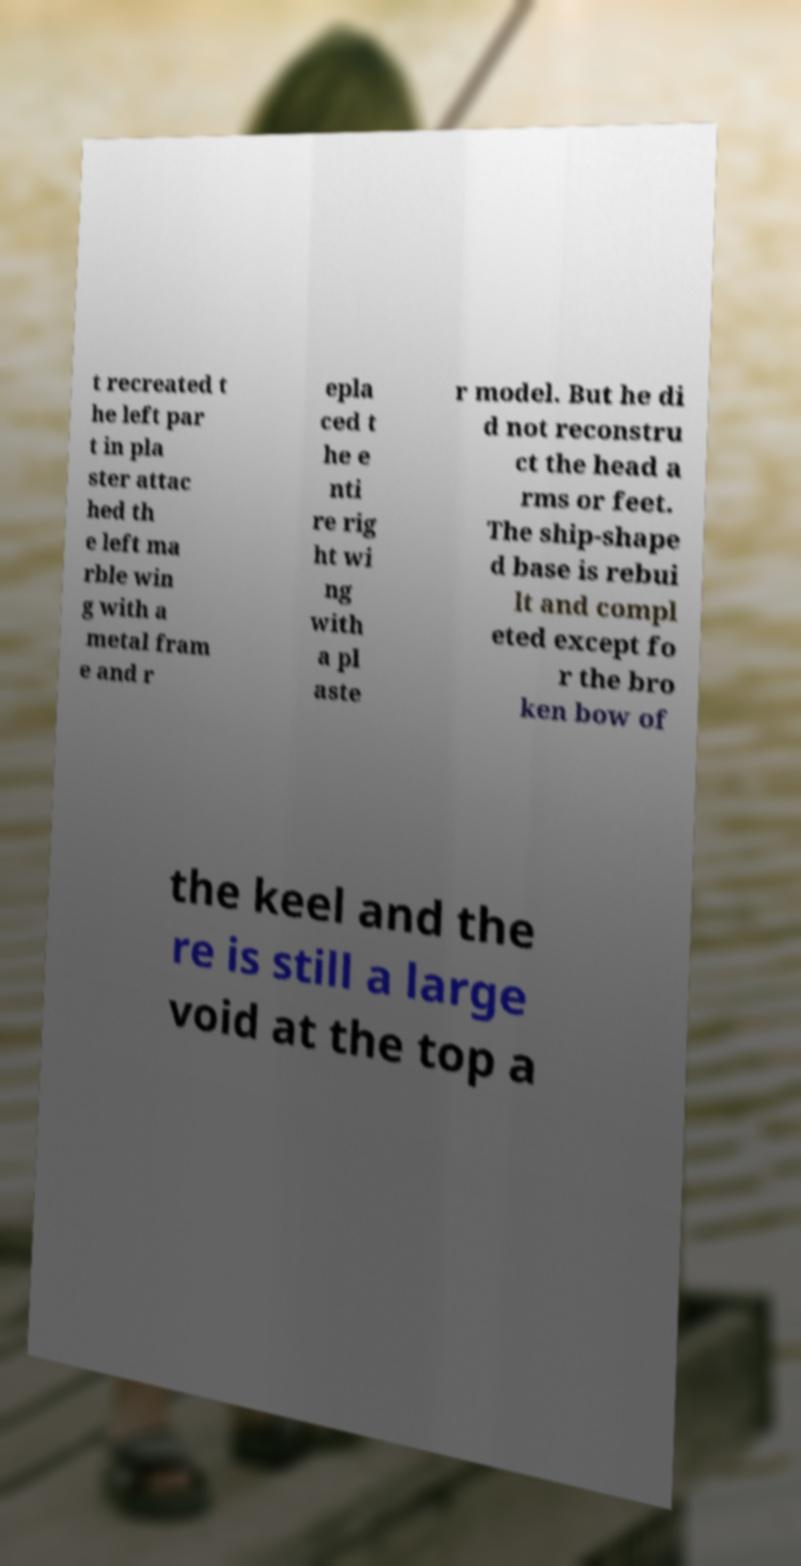For documentation purposes, I need the text within this image transcribed. Could you provide that? t recreated t he left par t in pla ster attac hed th e left ma rble win g with a metal fram e and r epla ced t he e nti re rig ht wi ng with a pl aste r model. But he di d not reconstru ct the head a rms or feet. The ship-shape d base is rebui lt and compl eted except fo r the bro ken bow of the keel and the re is still a large void at the top a 